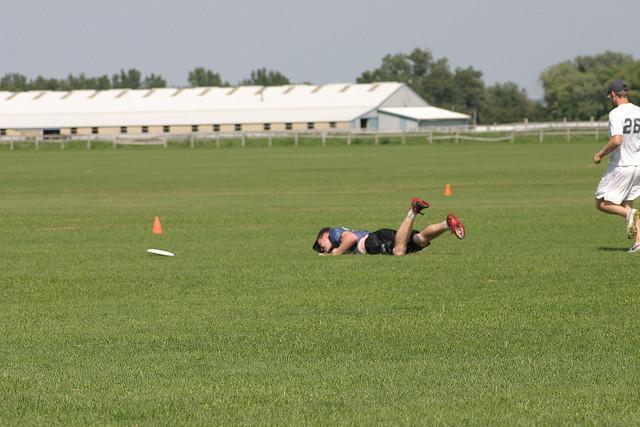How many people are in the photo?
Give a very brief answer. 2. 